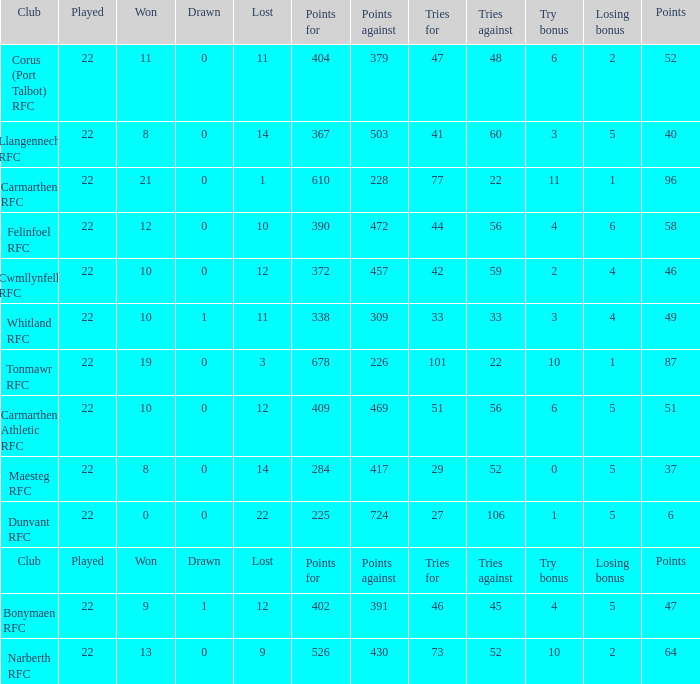Name the tries against for drawn 1.0. 